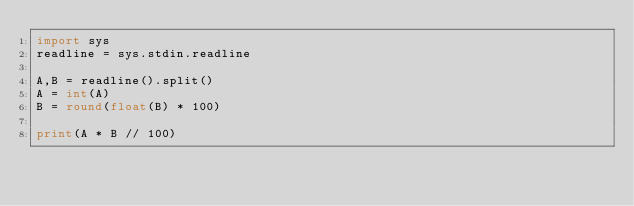<code> <loc_0><loc_0><loc_500><loc_500><_Python_>import sys
readline = sys.stdin.readline

A,B = readline().split()
A = int(A)
B = round(float(B) * 100)

print(A * B // 100)

</code> 